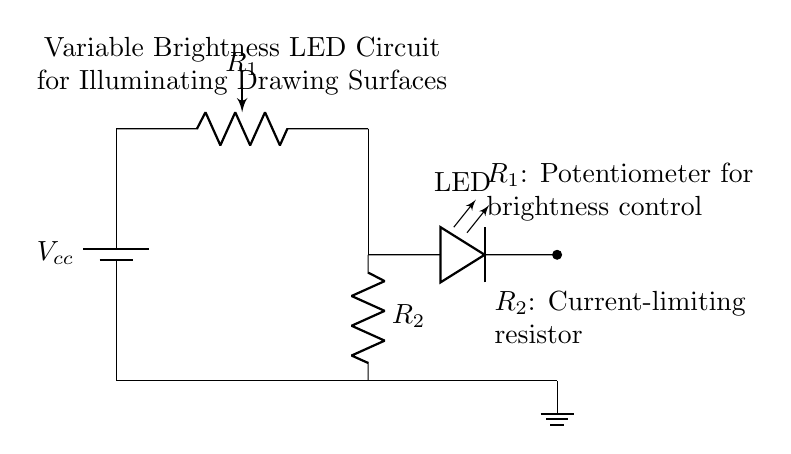What is the value of the potentiometer in the circuit? The circuit diagram labels the potentiometer as $R_1$, but does not specify its resistance value. Typically, potentiometers can vary in resistance, like from 0 to 10k ohms, depending on the design requirements.
Answer: Variable What does the LED represent in this circuit? The LED, labeled as LED in the diagram, acts as an indicator light and source of brightness for illuminating drawing surfaces by lighting up when current flows through it.
Answer: Illumination What is the function of $R_2$ in the circuit? $R_2$ is the current-limiting resistor, which restricts the amount of current flowing through the LED to prevent it from burning out, as LEDs are sensitive to excessive currents.
Answer: Current limit How does adjusting $R_1$ affect the LED brightness? Adjusting $R_1$, the potentiometer, changes its resistance, which alters the current that flows through the LED. A higher resistance results in lower current and dimmer LED brightness, while lower resistance increases current and brightness.
Answer: Brightness control What type of circuit is this? This circuit is a variable brightness LED circuit designed to illuminate drawing surfaces; it allows for adjustment in brightness via a potentiometer.
Answer: Variable brightness How is the circuit grounded? The circuit is grounded by connecting the ground symbol at the bottom of the diagram to the negative terminal of the battery, establishing a common reference point for the circuit.
Answer: Grounded at the battery 